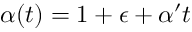<formula> <loc_0><loc_0><loc_500><loc_500>\alpha ( t ) = 1 + \epsilon + \alpha ^ { \prime } t</formula> 